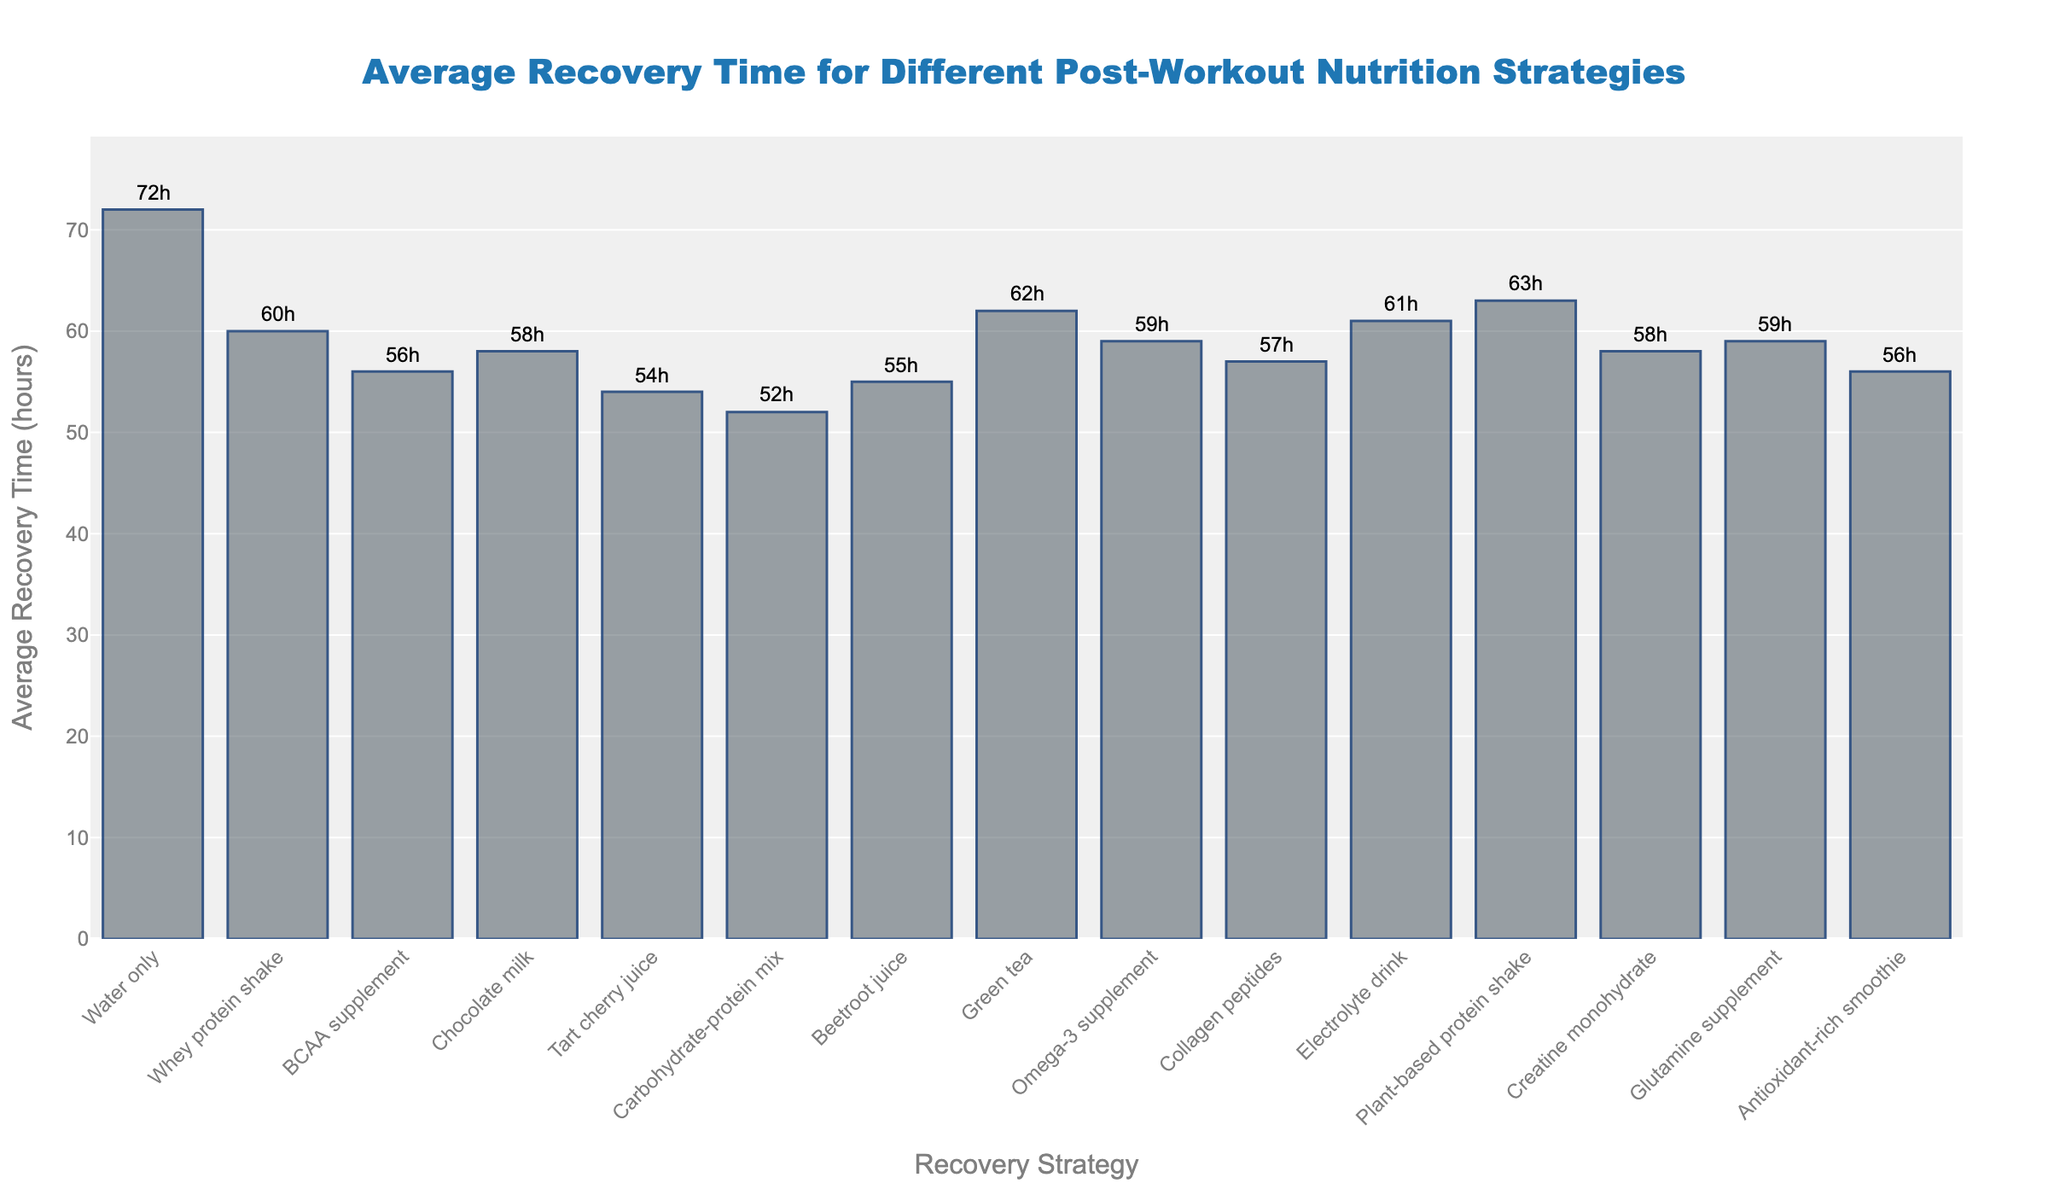What's the post-workout nutrition strategy that results in the shortest average recovery time? By looking at the figure, identify the bar with the lowest height, which indicates the shortest average recovery time.
Answer: Carbohydrate-protein mix How much shorter is the recovery time for BCAA supplement compared to Water only? Determine the average recovery times for BCAA supplement (56 hours) and Water only (72 hours), and then subtract the former from the latter: 72 - 56 = 16 hours.
Answer: 16 hours Which two strategies have almost equal average recovery times? Find the bars with similar heights. Chocolate milk (58 hours) and Creatine monohydrate (58 hours) have almost equal average recovery times.
Answer: Chocolate milk and Creatine monohydrate What is the difference in average recovery time between the strategy with the shortest and the longest recovery times? Identify the shortest (Carbohydrate-protein mix: 52 hours) and longest (Water only: 72 hours) average recovery times, and subtract the shortest from the longest: 72 - 52 = 20 hours.
Answer: 20 hours Which strategy has a recovery time closest to 60 hours but less than that? By examining the figure, the bar for Whey protein shake is closest to but less than 60 hours with an average recovery time of 60 hours itself. Since it is exactly 60 hours and not less, consider Beetroot juice with an average recovery time of 55 hours for the next closest and less than 60 hours.
Answer: Beetroot juice Order the strategies from shortest to longest average recovery time. List the strategies according to the height of the bars in ascending order: Carbohydrate-protein mix, Tart cherry juice, Beetroot juice, BCAA supplement, Chocolate milk, Creatine monohydrate, Collagen peptides, Antioxidant-rich smoothie, Glutamine supplement, Omega-3 supplement, Whey protein shake, Electrolyte drink, Green tea, Plant-based protein shake, Water only.
Answer: Carbohydrate-protein mix, Tart cherry juice, Beetroot juice, BCAA supplement, Chocolate milk, Creatine monohydrate, Collagen peptides, Antioxidant-rich smoothie, Glutamine supplement, Omega-3 supplement, Whey protein shake, Electrolyte drink, Green tea, Plant-based protein shake, Water only 